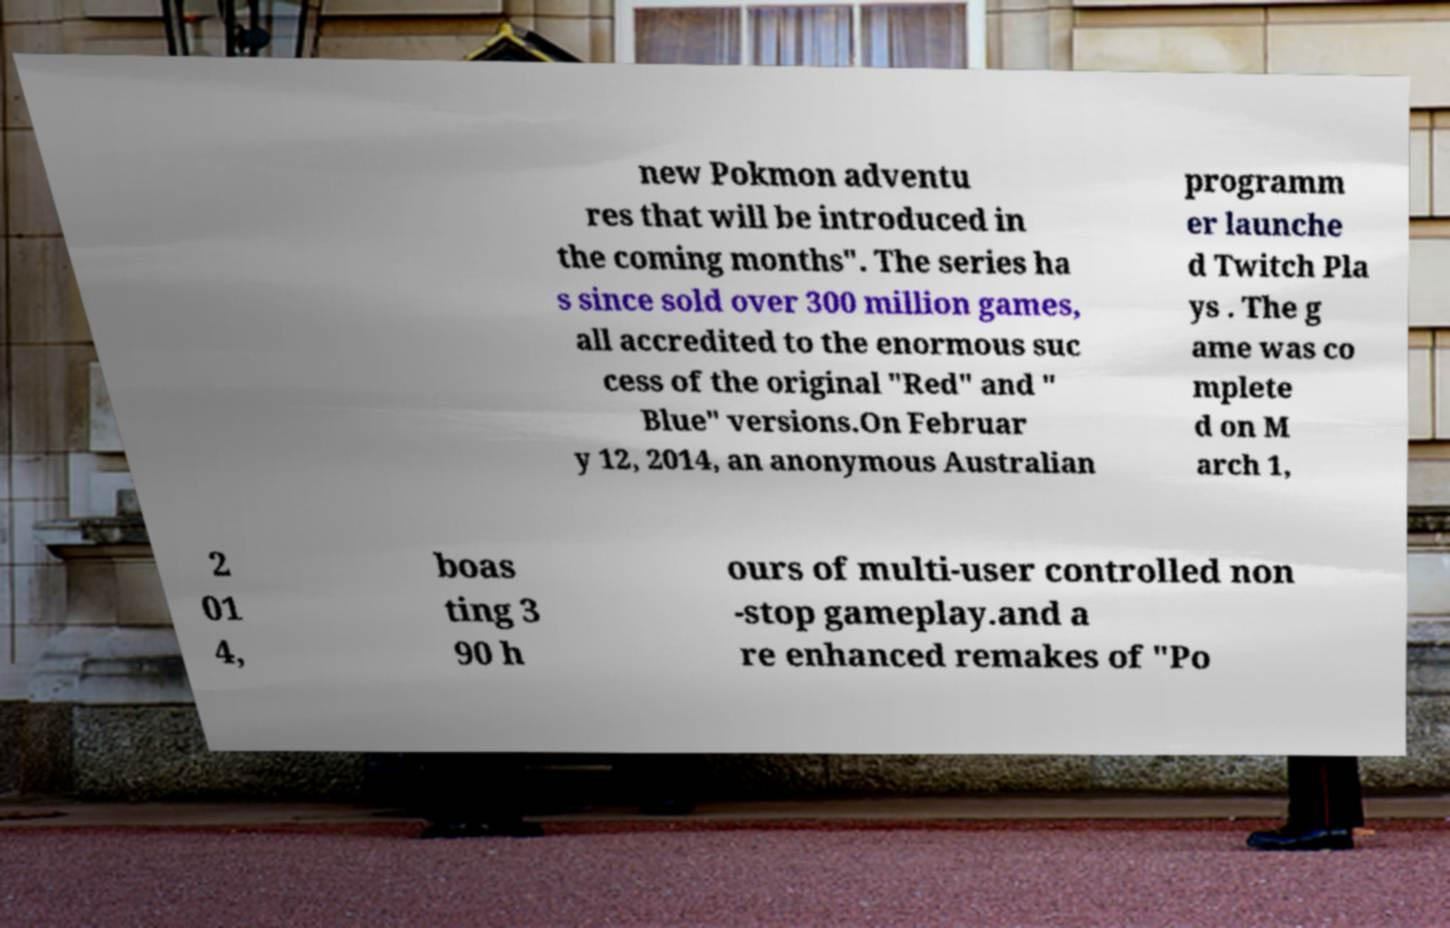Can you read and provide the text displayed in the image?This photo seems to have some interesting text. Can you extract and type it out for me? new Pokmon adventu res that will be introduced in the coming months". The series ha s since sold over 300 million games, all accredited to the enormous suc cess of the original "Red" and " Blue" versions.On Februar y 12, 2014, an anonymous Australian programm er launche d Twitch Pla ys . The g ame was co mplete d on M arch 1, 2 01 4, boas ting 3 90 h ours of multi-user controlled non -stop gameplay.and a re enhanced remakes of "Po 